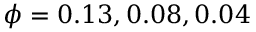<formula> <loc_0><loc_0><loc_500><loc_500>\phi = 0 . 1 3 , 0 . 0 8 , 0 . 0 4</formula> 